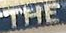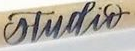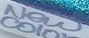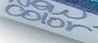What words can you see in these images in sequence, separated by a semicolon? THE; studir; New; color 